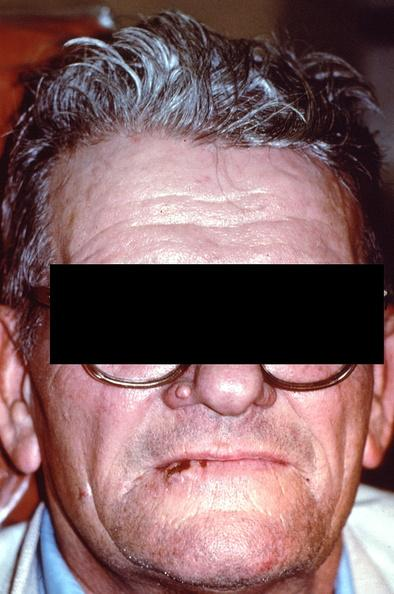what does this image show?
Answer the question using a single word or phrase. Squamous cell carcinoma 